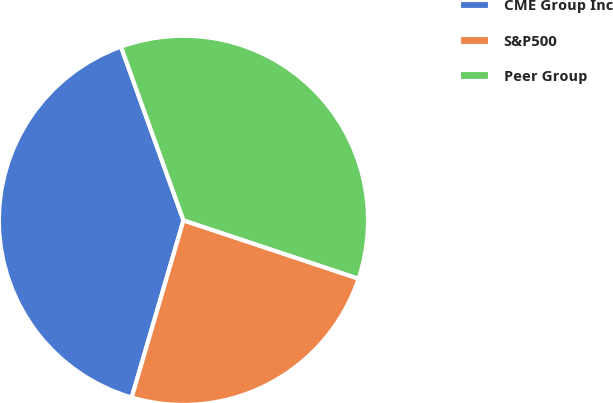Convert chart to OTSL. <chart><loc_0><loc_0><loc_500><loc_500><pie_chart><fcel>CME Group Inc<fcel>S&P500<fcel>Peer Group<nl><fcel>39.98%<fcel>24.41%<fcel>35.62%<nl></chart> 